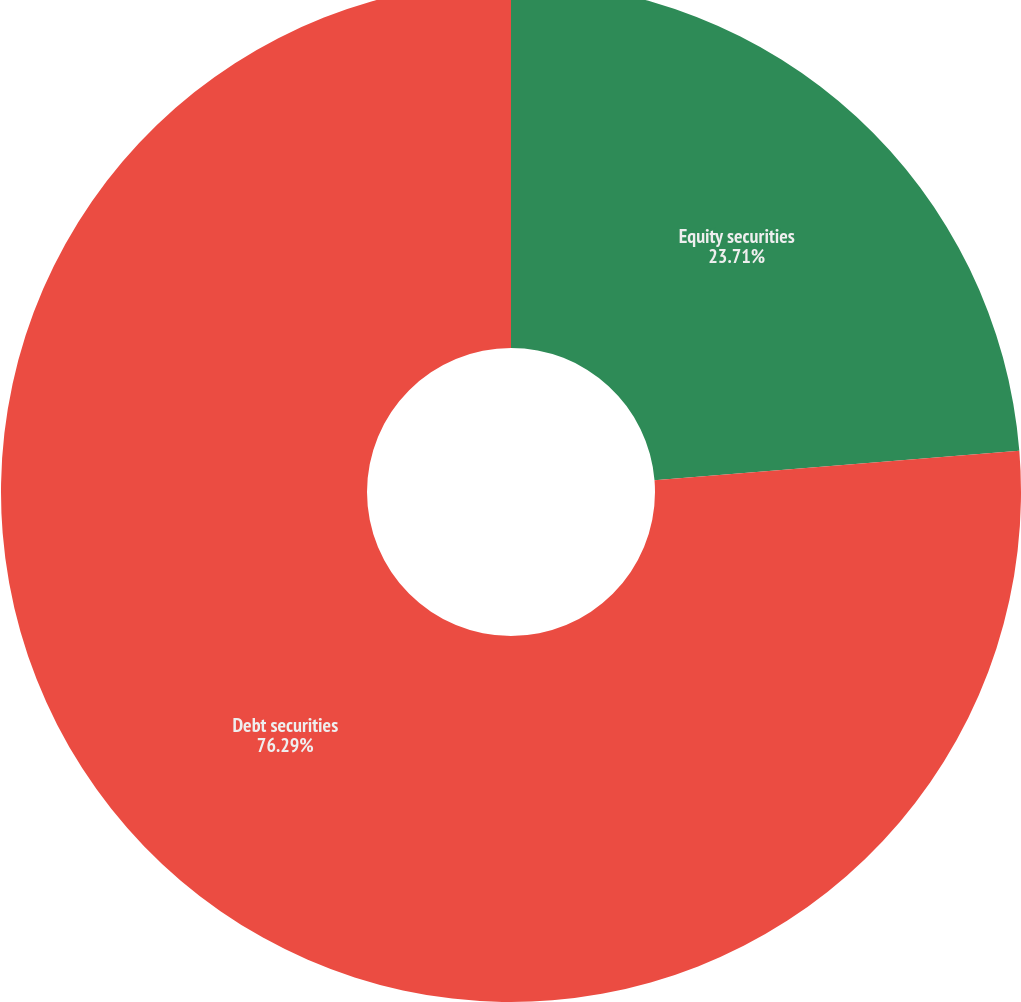<chart> <loc_0><loc_0><loc_500><loc_500><pie_chart><fcel>Equity securities<fcel>Debt securities<nl><fcel>23.71%<fcel>76.29%<nl></chart> 